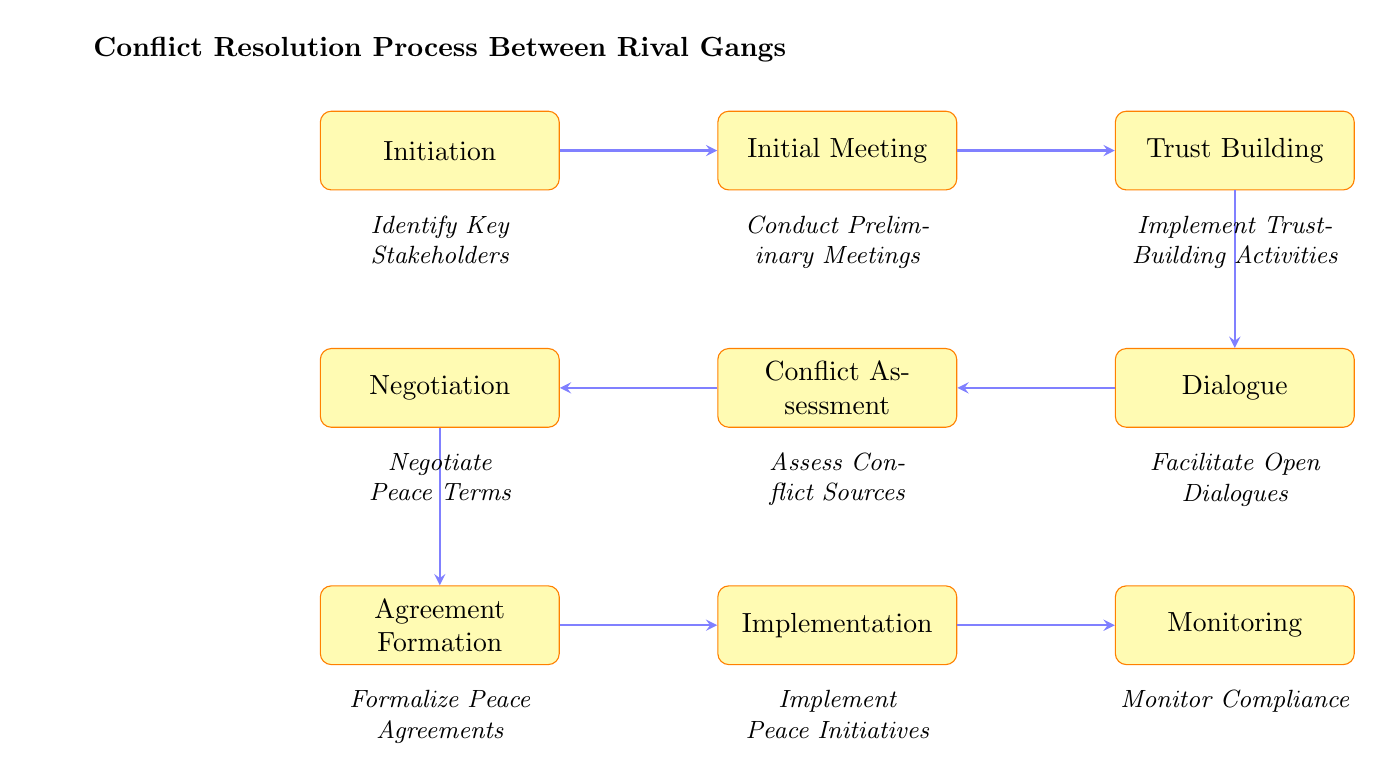What is the first node in the conflict resolution process? The diagram starts with the node labeled "Initiation," which is the first step in the flow.
Answer: Initiation How many nodes are present in the diagram? By counting each distinct step in the process, there are a total of nine nodes displayed in the flow chart.
Answer: 9 Which node follows "Trust Building"? The node immediately after "Trust Building" in the flow is "Dialogue," indicating the next step in the process.
Answer: Dialogue What key activity takes place during "Conflict Assessment"? The description for "Conflict Assessment" states that it involves identifying and analyzing the root causes of conflicts.
Answer: Identify and analyze root causes What are the last two steps in the conflict resolution process? Looking at the end of the diagram, the last two steps are "Implementation" followed by "Monitoring," which come sequentially.
Answer: Implementation, Monitoring Which node includes joint community service projects? The "Trust Building" node specifically mentions implementing trust-building activities, including organizing joint community service projects.
Answer: Trust Building What is the role of the "Monitoring" node? The "Monitoring" node is included to address ongoing compliance and issues that may arise following the implementation, indicating its role in oversight.
Answer: Monitor compliance and address issues How do you formalize peace agreements according to the diagram? "Agreement Formation" describes that peace agreements are formalized by signing formal peace accords witnessed by community leaders, indicating a necessary step for validation.
Answer: Sign formal peace accords Which node comes before "Negotiation"? The node preceding "Negotiation" is "Conflict Assessment," indicating a necessary analysis of conflicts before moving on to negotiate terms.
Answer: Conflict Assessment 